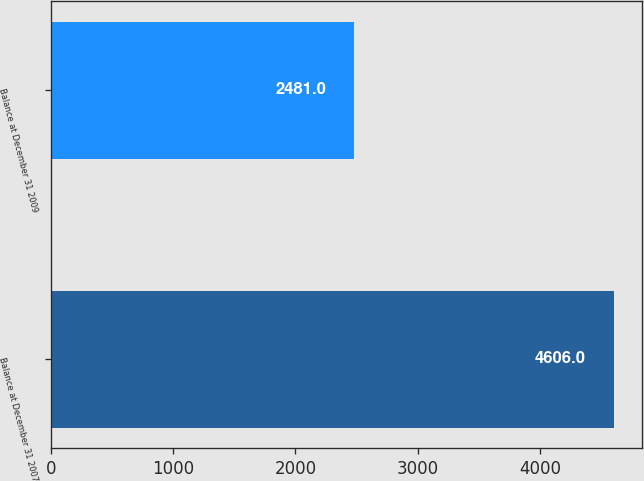Convert chart to OTSL. <chart><loc_0><loc_0><loc_500><loc_500><bar_chart><fcel>Balance at December 31 2007<fcel>Balance at December 31 2009<nl><fcel>4606<fcel>2481<nl></chart> 